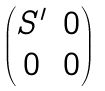<formula> <loc_0><loc_0><loc_500><loc_500>\begin{pmatrix} S ^ { \prime } & 0 \\ 0 & 0 \end{pmatrix}</formula> 